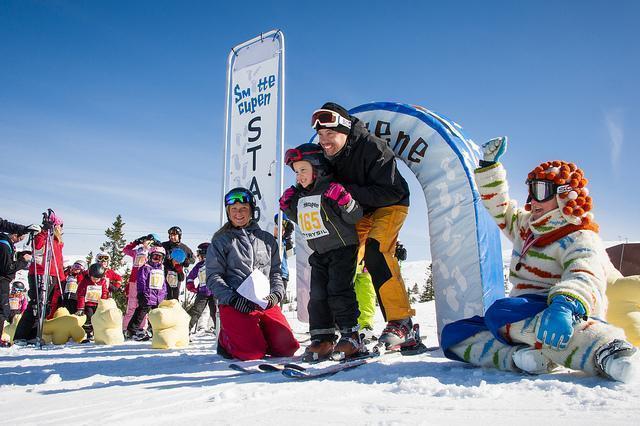Why are the children wearing numbers on their jackets?
Indicate the correct response and explain using: 'Answer: answer
Rationale: rationale.'
Options: For fun, for style, as punishment, for competition. Answer: for competition.
Rationale: The kids are competing. 